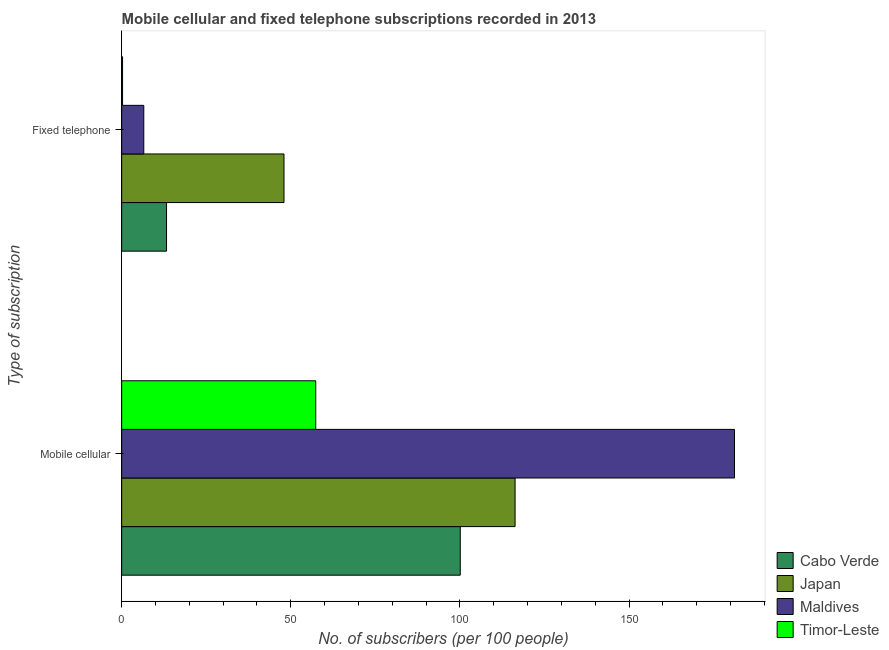How many groups of bars are there?
Keep it short and to the point. 2. Are the number of bars per tick equal to the number of legend labels?
Ensure brevity in your answer.  Yes. What is the label of the 2nd group of bars from the top?
Your answer should be compact. Mobile cellular. What is the number of fixed telephone subscribers in Maldives?
Your answer should be very brief. 6.54. Across all countries, what is the maximum number of mobile cellular subscribers?
Provide a succinct answer. 181.19. Across all countries, what is the minimum number of mobile cellular subscribers?
Your response must be concise. 57.38. In which country was the number of fixed telephone subscribers maximum?
Your response must be concise. Japan. In which country was the number of mobile cellular subscribers minimum?
Provide a succinct answer. Timor-Leste. What is the total number of fixed telephone subscribers in the graph?
Make the answer very short. 68.06. What is the difference between the number of fixed telephone subscribers in Cabo Verde and that in Japan?
Make the answer very short. -34.73. What is the difference between the number of mobile cellular subscribers in Maldives and the number of fixed telephone subscribers in Timor-Leste?
Your response must be concise. 180.93. What is the average number of mobile cellular subscribers per country?
Provide a succinct answer. 113.75. What is the difference between the number of mobile cellular subscribers and number of fixed telephone subscribers in Timor-Leste?
Make the answer very short. 57.11. In how many countries, is the number of fixed telephone subscribers greater than 40 ?
Keep it short and to the point. 1. What is the ratio of the number of fixed telephone subscribers in Maldives to that in Japan?
Offer a terse response. 0.14. Is the number of mobile cellular subscribers in Japan less than that in Timor-Leste?
Ensure brevity in your answer.  No. What does the 3rd bar from the top in Mobile cellular represents?
Ensure brevity in your answer.  Japan. What does the 1st bar from the bottom in Fixed telephone represents?
Make the answer very short. Cabo Verde. How many bars are there?
Your response must be concise. 8. Are all the bars in the graph horizontal?
Offer a terse response. Yes. Are the values on the major ticks of X-axis written in scientific E-notation?
Make the answer very short. No. How many legend labels are there?
Your answer should be very brief. 4. What is the title of the graph?
Give a very brief answer. Mobile cellular and fixed telephone subscriptions recorded in 2013. Does "Argentina" appear as one of the legend labels in the graph?
Your answer should be very brief. No. What is the label or title of the X-axis?
Provide a succinct answer. No. of subscribers (per 100 people). What is the label or title of the Y-axis?
Give a very brief answer. Type of subscription. What is the No. of subscribers (per 100 people) of Cabo Verde in Mobile cellular?
Your response must be concise. 100.11. What is the No. of subscribers (per 100 people) in Japan in Mobile cellular?
Give a very brief answer. 116.32. What is the No. of subscribers (per 100 people) of Maldives in Mobile cellular?
Your answer should be compact. 181.19. What is the No. of subscribers (per 100 people) in Timor-Leste in Mobile cellular?
Your answer should be very brief. 57.38. What is the No. of subscribers (per 100 people) of Cabo Verde in Fixed telephone?
Offer a very short reply. 13.26. What is the No. of subscribers (per 100 people) of Japan in Fixed telephone?
Provide a short and direct response. 47.99. What is the No. of subscribers (per 100 people) in Maldives in Fixed telephone?
Keep it short and to the point. 6.54. What is the No. of subscribers (per 100 people) in Timor-Leste in Fixed telephone?
Your answer should be compact. 0.26. Across all Type of subscription, what is the maximum No. of subscribers (per 100 people) in Cabo Verde?
Provide a succinct answer. 100.11. Across all Type of subscription, what is the maximum No. of subscribers (per 100 people) in Japan?
Offer a terse response. 116.32. Across all Type of subscription, what is the maximum No. of subscribers (per 100 people) in Maldives?
Make the answer very short. 181.19. Across all Type of subscription, what is the maximum No. of subscribers (per 100 people) in Timor-Leste?
Your answer should be compact. 57.38. Across all Type of subscription, what is the minimum No. of subscribers (per 100 people) of Cabo Verde?
Your answer should be very brief. 13.26. Across all Type of subscription, what is the minimum No. of subscribers (per 100 people) of Japan?
Your answer should be compact. 47.99. Across all Type of subscription, what is the minimum No. of subscribers (per 100 people) of Maldives?
Keep it short and to the point. 6.54. Across all Type of subscription, what is the minimum No. of subscribers (per 100 people) of Timor-Leste?
Your answer should be very brief. 0.26. What is the total No. of subscribers (per 100 people) of Cabo Verde in the graph?
Offer a terse response. 113.38. What is the total No. of subscribers (per 100 people) of Japan in the graph?
Offer a very short reply. 164.31. What is the total No. of subscribers (per 100 people) in Maldives in the graph?
Give a very brief answer. 187.73. What is the total No. of subscribers (per 100 people) in Timor-Leste in the graph?
Your answer should be very brief. 57.64. What is the difference between the No. of subscribers (per 100 people) in Cabo Verde in Mobile cellular and that in Fixed telephone?
Your answer should be very brief. 86.85. What is the difference between the No. of subscribers (per 100 people) in Japan in Mobile cellular and that in Fixed telephone?
Provide a short and direct response. 68.32. What is the difference between the No. of subscribers (per 100 people) in Maldives in Mobile cellular and that in Fixed telephone?
Provide a short and direct response. 174.66. What is the difference between the No. of subscribers (per 100 people) of Timor-Leste in Mobile cellular and that in Fixed telephone?
Offer a terse response. 57.11. What is the difference between the No. of subscribers (per 100 people) of Cabo Verde in Mobile cellular and the No. of subscribers (per 100 people) of Japan in Fixed telephone?
Provide a short and direct response. 52.12. What is the difference between the No. of subscribers (per 100 people) in Cabo Verde in Mobile cellular and the No. of subscribers (per 100 people) in Maldives in Fixed telephone?
Give a very brief answer. 93.57. What is the difference between the No. of subscribers (per 100 people) in Cabo Verde in Mobile cellular and the No. of subscribers (per 100 people) in Timor-Leste in Fixed telephone?
Offer a terse response. 99.85. What is the difference between the No. of subscribers (per 100 people) of Japan in Mobile cellular and the No. of subscribers (per 100 people) of Maldives in Fixed telephone?
Keep it short and to the point. 109.78. What is the difference between the No. of subscribers (per 100 people) in Japan in Mobile cellular and the No. of subscribers (per 100 people) in Timor-Leste in Fixed telephone?
Keep it short and to the point. 116.05. What is the difference between the No. of subscribers (per 100 people) of Maldives in Mobile cellular and the No. of subscribers (per 100 people) of Timor-Leste in Fixed telephone?
Your response must be concise. 180.93. What is the average No. of subscribers (per 100 people) of Cabo Verde per Type of subscription?
Offer a very short reply. 56.69. What is the average No. of subscribers (per 100 people) of Japan per Type of subscription?
Provide a succinct answer. 82.15. What is the average No. of subscribers (per 100 people) of Maldives per Type of subscription?
Give a very brief answer. 93.87. What is the average No. of subscribers (per 100 people) of Timor-Leste per Type of subscription?
Give a very brief answer. 28.82. What is the difference between the No. of subscribers (per 100 people) in Cabo Verde and No. of subscribers (per 100 people) in Japan in Mobile cellular?
Offer a terse response. -16.2. What is the difference between the No. of subscribers (per 100 people) in Cabo Verde and No. of subscribers (per 100 people) in Maldives in Mobile cellular?
Offer a very short reply. -81.08. What is the difference between the No. of subscribers (per 100 people) of Cabo Verde and No. of subscribers (per 100 people) of Timor-Leste in Mobile cellular?
Offer a terse response. 42.74. What is the difference between the No. of subscribers (per 100 people) in Japan and No. of subscribers (per 100 people) in Maldives in Mobile cellular?
Provide a succinct answer. -64.88. What is the difference between the No. of subscribers (per 100 people) of Japan and No. of subscribers (per 100 people) of Timor-Leste in Mobile cellular?
Keep it short and to the point. 58.94. What is the difference between the No. of subscribers (per 100 people) in Maldives and No. of subscribers (per 100 people) in Timor-Leste in Mobile cellular?
Provide a succinct answer. 123.82. What is the difference between the No. of subscribers (per 100 people) of Cabo Verde and No. of subscribers (per 100 people) of Japan in Fixed telephone?
Provide a succinct answer. -34.73. What is the difference between the No. of subscribers (per 100 people) of Cabo Verde and No. of subscribers (per 100 people) of Maldives in Fixed telephone?
Your answer should be very brief. 6.73. What is the difference between the No. of subscribers (per 100 people) of Cabo Verde and No. of subscribers (per 100 people) of Timor-Leste in Fixed telephone?
Your answer should be compact. 13. What is the difference between the No. of subscribers (per 100 people) of Japan and No. of subscribers (per 100 people) of Maldives in Fixed telephone?
Keep it short and to the point. 41.45. What is the difference between the No. of subscribers (per 100 people) in Japan and No. of subscribers (per 100 people) in Timor-Leste in Fixed telephone?
Your response must be concise. 47.73. What is the difference between the No. of subscribers (per 100 people) in Maldives and No. of subscribers (per 100 people) in Timor-Leste in Fixed telephone?
Keep it short and to the point. 6.27. What is the ratio of the No. of subscribers (per 100 people) in Cabo Verde in Mobile cellular to that in Fixed telephone?
Keep it short and to the point. 7.55. What is the ratio of the No. of subscribers (per 100 people) of Japan in Mobile cellular to that in Fixed telephone?
Keep it short and to the point. 2.42. What is the ratio of the No. of subscribers (per 100 people) in Maldives in Mobile cellular to that in Fixed telephone?
Make the answer very short. 27.71. What is the ratio of the No. of subscribers (per 100 people) of Timor-Leste in Mobile cellular to that in Fixed telephone?
Offer a very short reply. 216.67. What is the difference between the highest and the second highest No. of subscribers (per 100 people) of Cabo Verde?
Offer a very short reply. 86.85. What is the difference between the highest and the second highest No. of subscribers (per 100 people) of Japan?
Your answer should be compact. 68.32. What is the difference between the highest and the second highest No. of subscribers (per 100 people) in Maldives?
Offer a very short reply. 174.66. What is the difference between the highest and the second highest No. of subscribers (per 100 people) of Timor-Leste?
Keep it short and to the point. 57.11. What is the difference between the highest and the lowest No. of subscribers (per 100 people) of Cabo Verde?
Your response must be concise. 86.85. What is the difference between the highest and the lowest No. of subscribers (per 100 people) in Japan?
Give a very brief answer. 68.32. What is the difference between the highest and the lowest No. of subscribers (per 100 people) of Maldives?
Your answer should be compact. 174.66. What is the difference between the highest and the lowest No. of subscribers (per 100 people) of Timor-Leste?
Keep it short and to the point. 57.11. 